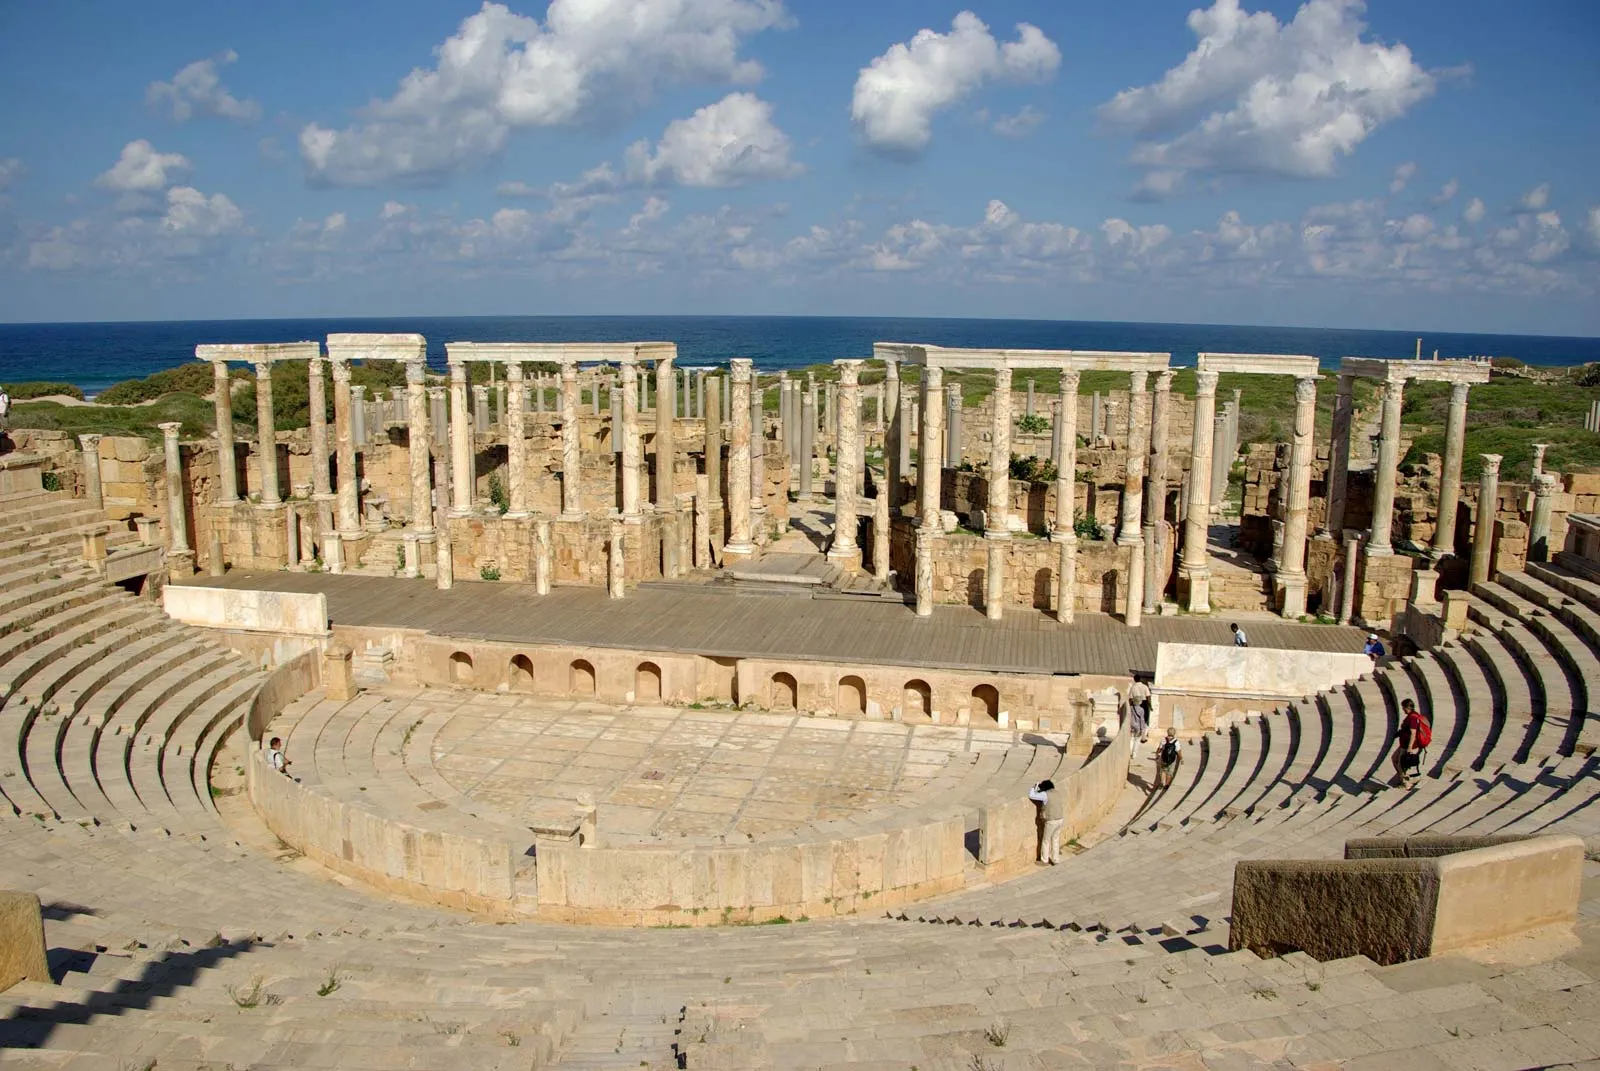Could you tell me more about the significance of this site in the context of ancient history? Leptis Magna, once a prominent city of the Roman Empire located in modern-day Libya, stands as a remarkable testament to ancient urban engineering and culture. Established by the Phoenicians around the 7th century BC and later flourishing under Roman rule, it became a crucial trade and cultural hub. The site's grandeur is most evident in its public spaces, such as the spectacular amphitheater shown in the image, which served as a venue for various public spectacles, including gladiator contests and dramatic performances. Its ruins are a treasure trove of Roman architecture and art, featuring well-preserved basilicas, markets, and baths, which provide invaluable insights into the life and sophistication of ancient civilizations. 